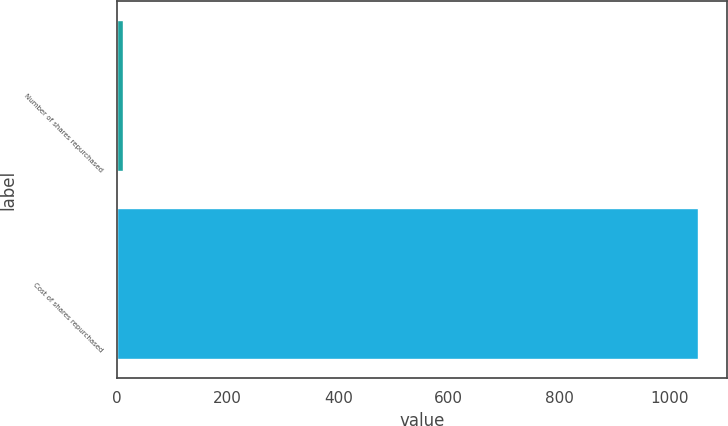Convert chart. <chart><loc_0><loc_0><loc_500><loc_500><bar_chart><fcel>Number of shares repurchased<fcel>Cost of shares repurchased<nl><fcel>10.7<fcel>1050<nl></chart> 